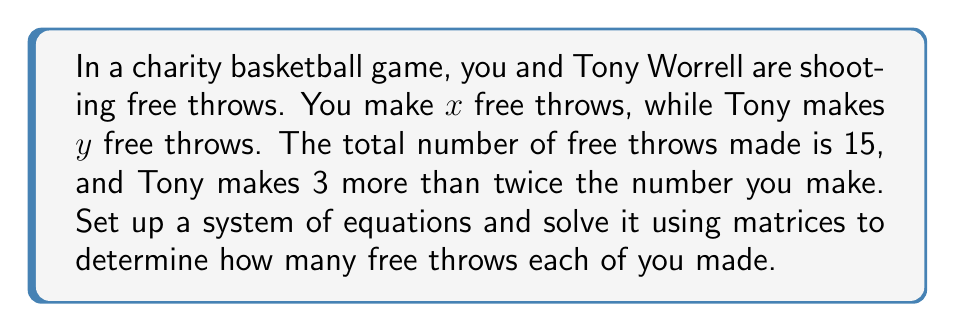Help me with this question. Let's approach this step-by-step:

1) First, we need to set up our system of equations:
   $$\begin{cases}
   x + y = 15 \\
   y = 2x + 3
   \end{cases}$$

2) Now, let's rewrite this in the form $AX = B$ where:
   $$A = \begin{bmatrix}
   1 & 1 \\
   -2 & 1
   \end{bmatrix},
   X = \begin{bmatrix}
   x \\
   y
   \end{bmatrix},
   B = \begin{bmatrix}
   15 \\
   3
   \end{bmatrix}$$

3) To solve this using matrices, we need to find $X = A^{-1}B$

4) First, let's find $A^{-1}$:
   $$A^{-1} = \frac{1}{det(A)} \begin{bmatrix}
   1 & -1 \\
   2 & 1
   \end{bmatrix}$$
   where $det(A) = 1(1) - 1(-2) = 3$

   So, $$A^{-1} = \frac{1}{3} \begin{bmatrix}
   1 & -1 \\
   2 & 1
   \end{bmatrix}$$

5) Now, we can calculate $X$:
   $$X = A^{-1}B = \frac{1}{3} \begin{bmatrix}
   1 & -1 \\
   2 & 1
   \end{bmatrix} \begin{bmatrix}
   15 \\
   3
   \end{bmatrix}$$

6) Multiplying these matrices:
   $$X = \frac{1}{3} \begin{bmatrix}
   1(15) + (-1)(3) \\
   2(15) + 1(3)
   \end{bmatrix} = \frac{1}{3} \begin{bmatrix}
   12 \\
   33
   \end{bmatrix} = \begin{bmatrix}
   4 \\
   11
   \end{bmatrix}$$

Therefore, you (x) made 4 free throws, and Tony (y) made 11 free throws.
Answer: You: 4, Tony: 11 